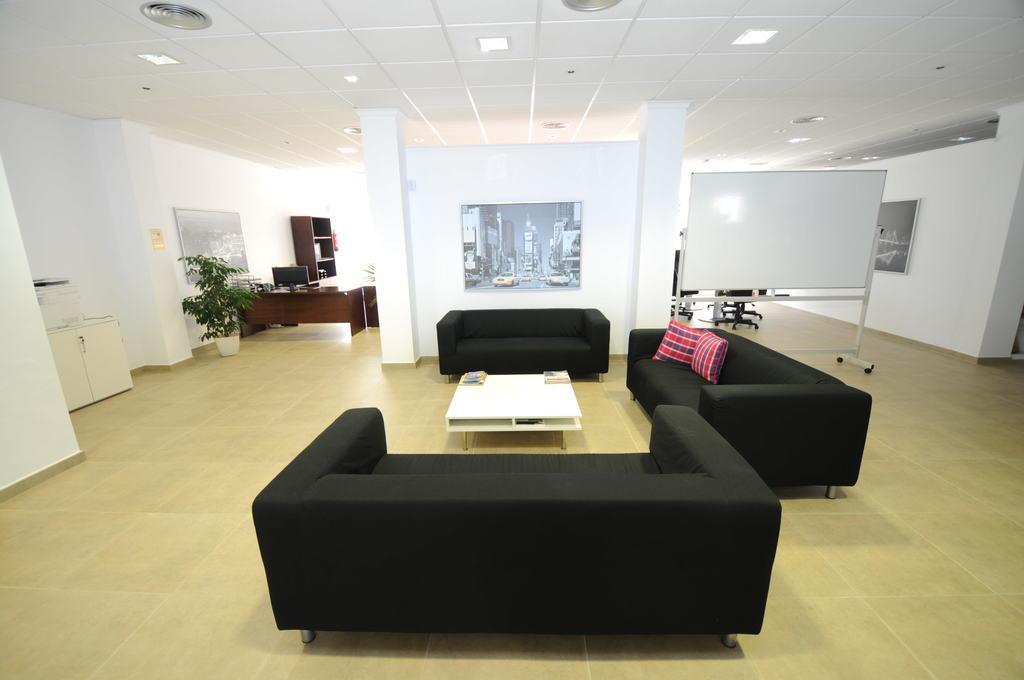In one or two sentences, can you explain what this image depicts? In the picture we can see a hall with three sofas, and near to it there is a white color table on one sofa there are two pillows, in the background we can see a plant, a wall with photo frame, and a white board, to the ceiling they are lights, and just beside the left we can see one cupboard, and to the right there is a wall and photo. 